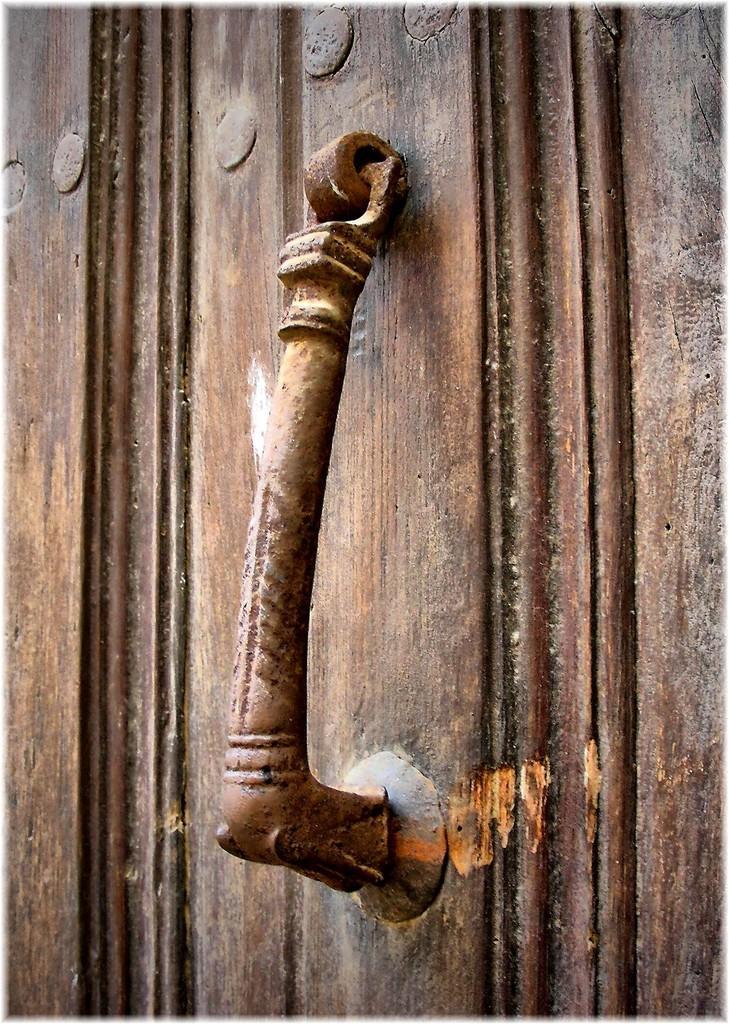Describe this image in one or two sentences. In the foreground of this image, there is a handle to a door. 